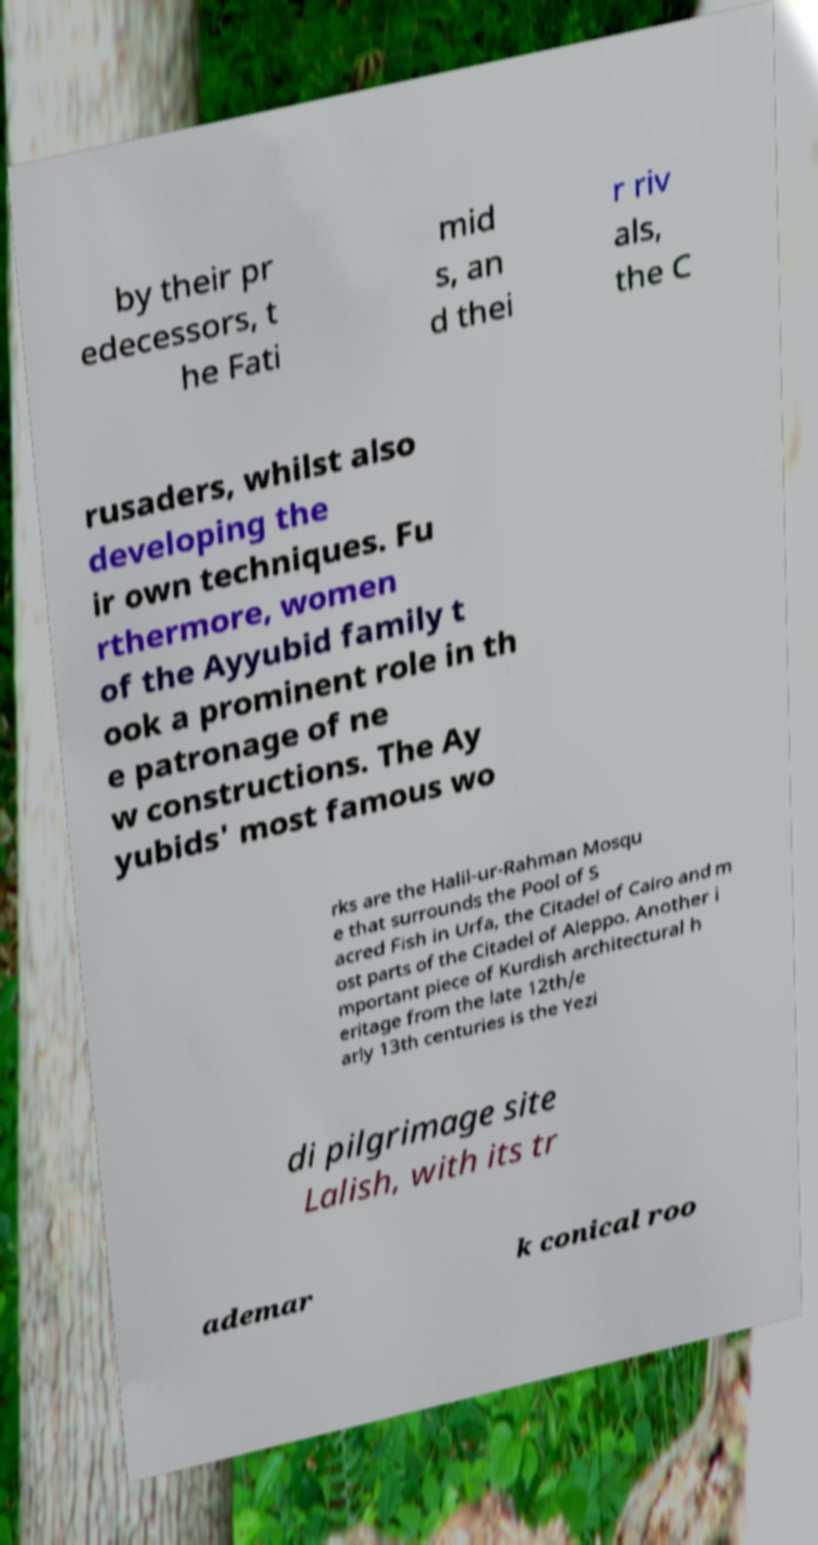What messages or text are displayed in this image? I need them in a readable, typed format. by their pr edecessors, t he Fati mid s, an d thei r riv als, the C rusaders, whilst also developing the ir own techniques. Fu rthermore, women of the Ayyubid family t ook a prominent role in th e patronage of ne w constructions. The Ay yubids' most famous wo rks are the Halil-ur-Rahman Mosqu e that surrounds the Pool of S acred Fish in Urfa, the Citadel of Cairo and m ost parts of the Citadel of Aleppo. Another i mportant piece of Kurdish architectural h eritage from the late 12th/e arly 13th centuries is the Yezi di pilgrimage site Lalish, with its tr ademar k conical roo 